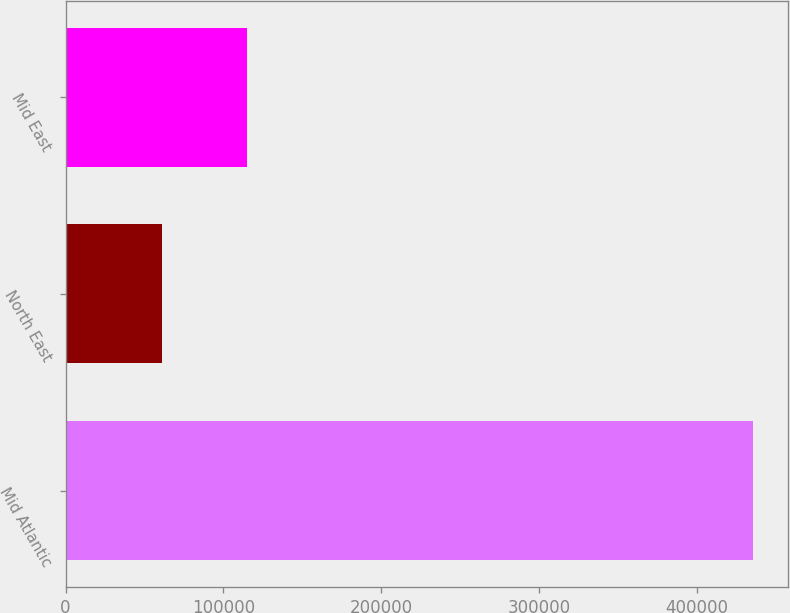Convert chart. <chart><loc_0><loc_0><loc_500><loc_500><bar_chart><fcel>Mid Atlantic<fcel>North East<fcel>Mid East<nl><fcel>435833<fcel>61233<fcel>115210<nl></chart> 